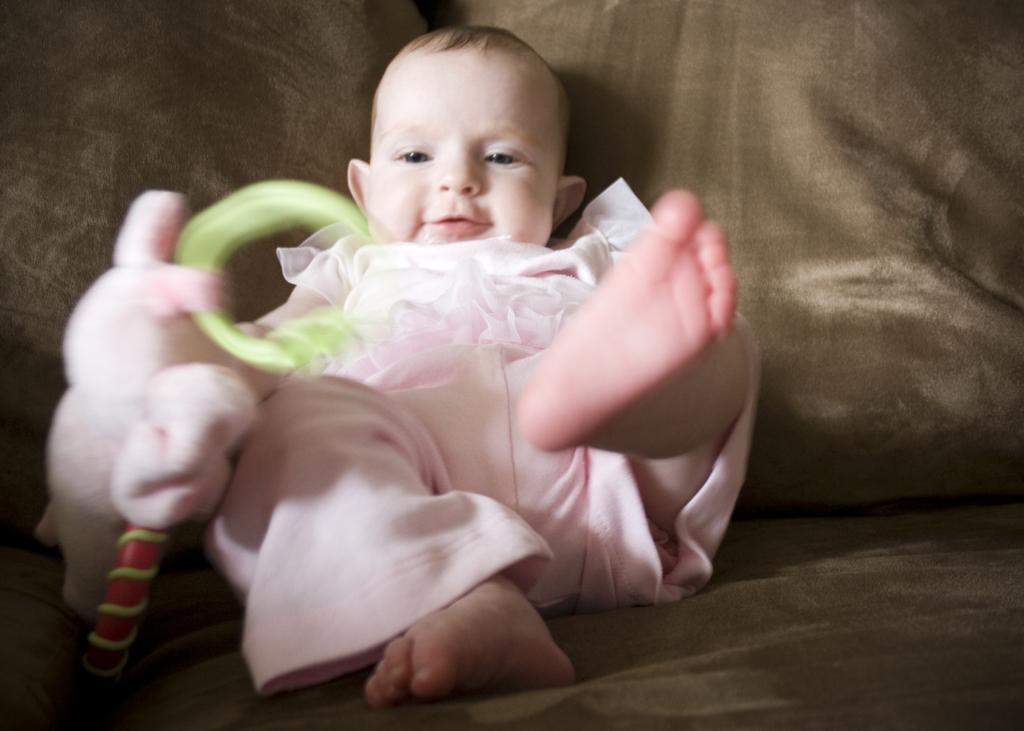What is the kid doing in the image? The kid is sitting on the sofa in the image. What can be seen on the left side of the image? There is a soft toy on the left side of the image. What type of discussion is the kid having with their dad in the image? There is no dad present in the image, and the kid is not engaged in any discussion. 